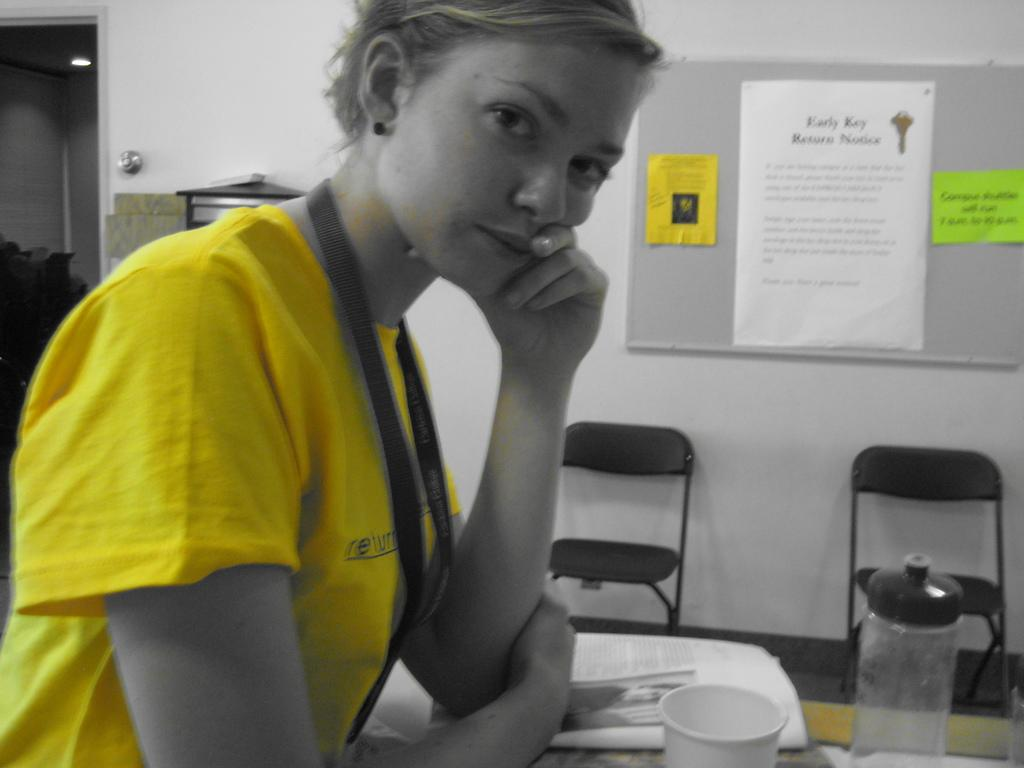<image>
Relay a brief, clear account of the picture shown. A lady with her hand on her face sitting at a desk with the word return on her yellow shirt. 